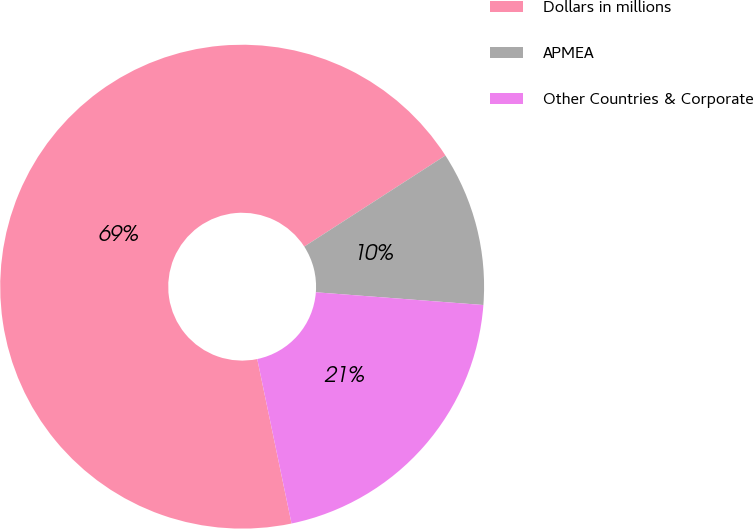Convert chart. <chart><loc_0><loc_0><loc_500><loc_500><pie_chart><fcel>Dollars in millions<fcel>APMEA<fcel>Other Countries & Corporate<nl><fcel>69.15%<fcel>10.33%<fcel>20.52%<nl></chart> 